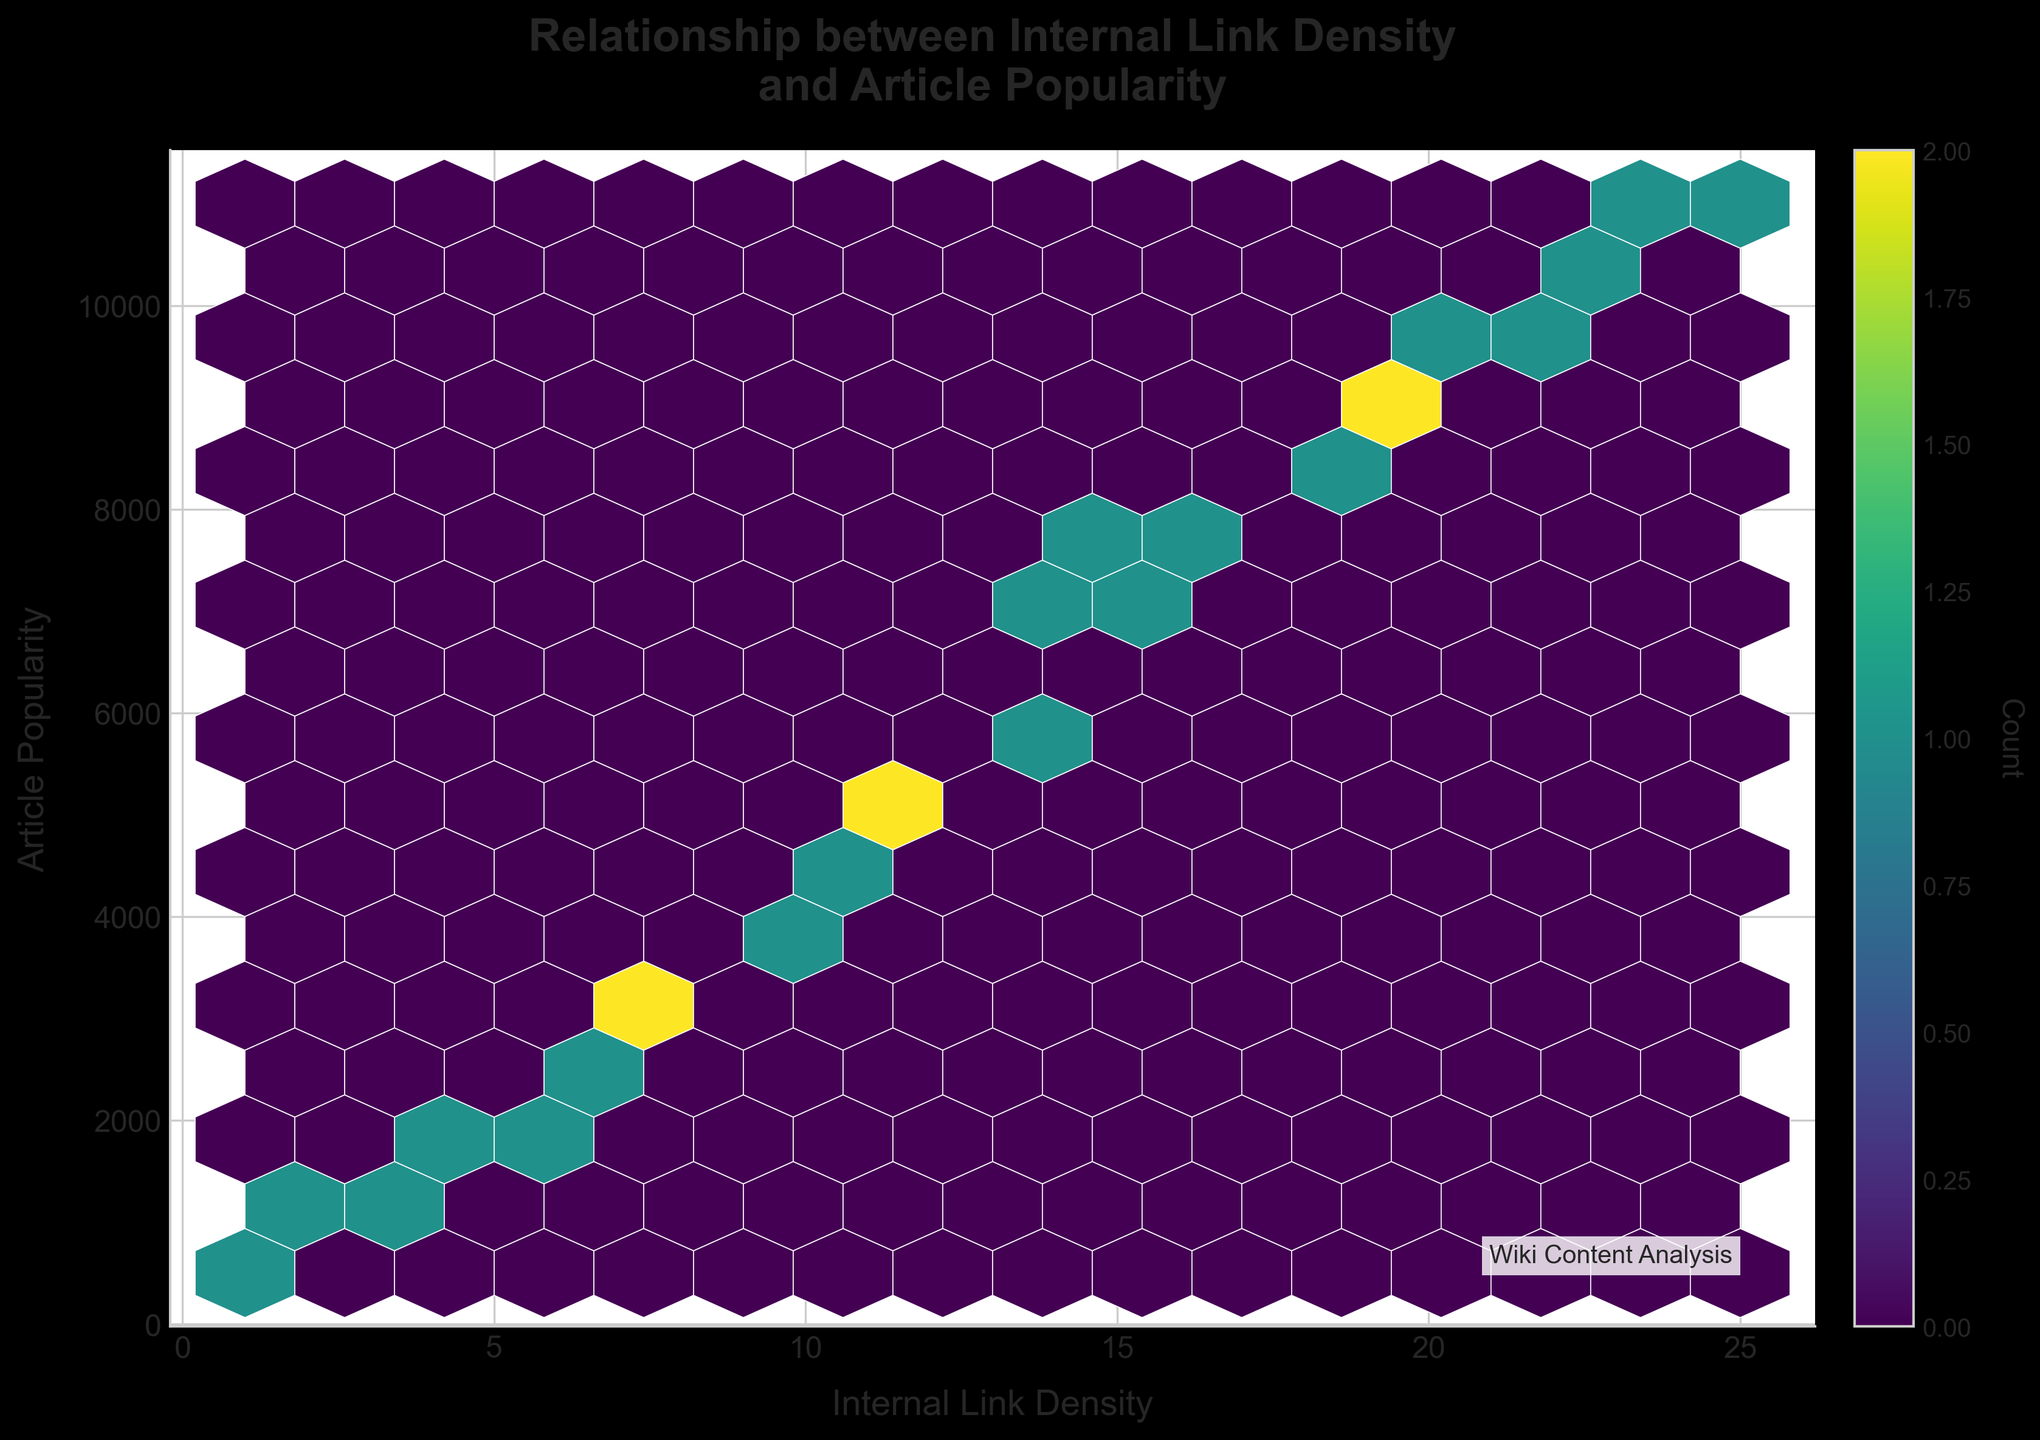What is the title of the hexbin plot? The title is located at the top-center of the plot. It reads 'Relationship between Internal Link Density and Article Popularity'.
Answer: Relationship between Internal Link Density and Article Popularity What does the x-axis represent? The x-axis label is located at the bottom of the plot and it represents 'Internal Link Density'.
Answer: Internal Link Density What is the y-axis label? The y-axis label is located to the left of the plot and it represents 'Article Popularity'.
Answer: Article Popularity How does the hexbin plot indicate the count of data points within each bin? The color of each hexbin cell represents the count of data points within that bin. The color intensity increases with higher counts, as shown in the color bar.
Answer: Color intensity What does the color bar label mean? The color bar on the right of the figure carries a label 'Count', which indicates the number of data points in each hexbin cell.
Answer: Count What is indicated by darker areas on the plot? Darker areas of the plot signify regions with a higher concentration of data points. This is demonstrated by the color gradient where darker colors indicate higher counts.
Answer: Higher concentration Is there a trend between internal link density and article popularity? Observing the distribution of data points, there appears to be a positive relationship between internal link density and article popularity, as higher link density regions generally correspond to higher popularity.
Answer: Positive relationship Where is the densest region of data points, and what does it indicate? The densest region on the hexbin plot appears around an internal link density of approximately 15-20 and article popularity of 7000-10000. This suggests that articles with these link densities are notably popular.
Answer: 15-20 link density, 7000-10000 popularity What is the maximum article popularity observed with a low internal link density? The region with the lowest internal link density (around 1) has an article popularity up to about 500.
Answer: 500 Which internal link density value corresponds to the highest article popularity? The highest article popularity, around 11000, corresponds to an internal link density of 25 as visible from the plot.
Answer: 25 Is there any region where article popularity does not exceed 5000? Yes, for internal link densities below approximately 10, article popularity generally does not exceed 5000. This can be seen in the lower left region of the plot.
Answer: Below 10 link density 